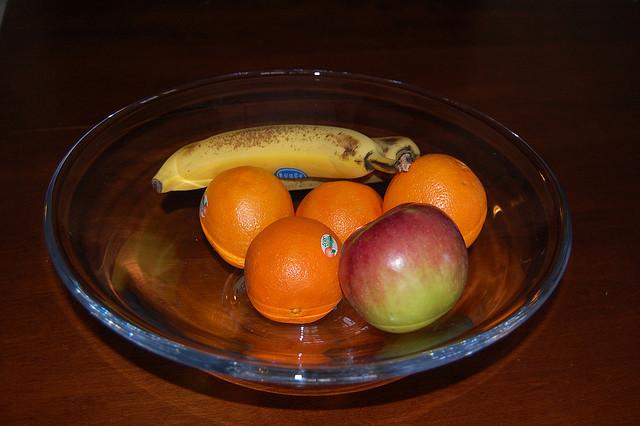How many kinds of fruit are there?
Answer briefly. 3. What is the bowl made of?
Keep it brief. Glass. How many fruits are in the bowl?
Write a very short answer. 7. How many types of fruits are shown?
Quick response, please. 3. How many of these fruits can be eaten without removing the peel?
Quick response, please. 1. 